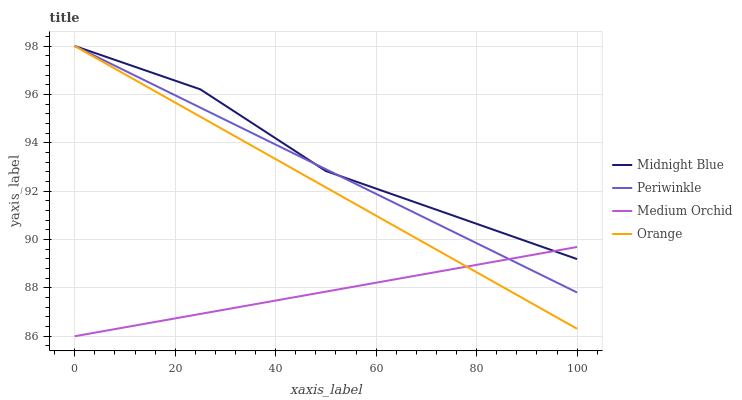Does Medium Orchid have the minimum area under the curve?
Answer yes or no. Yes. Does Midnight Blue have the maximum area under the curve?
Answer yes or no. Yes. Does Periwinkle have the minimum area under the curve?
Answer yes or no. No. Does Periwinkle have the maximum area under the curve?
Answer yes or no. No. Is Orange the smoothest?
Answer yes or no. Yes. Is Midnight Blue the roughest?
Answer yes or no. Yes. Is Medium Orchid the smoothest?
Answer yes or no. No. Is Medium Orchid the roughest?
Answer yes or no. No. Does Medium Orchid have the lowest value?
Answer yes or no. Yes. Does Periwinkle have the lowest value?
Answer yes or no. No. Does Midnight Blue have the highest value?
Answer yes or no. Yes. Does Medium Orchid have the highest value?
Answer yes or no. No. Does Medium Orchid intersect Orange?
Answer yes or no. Yes. Is Medium Orchid less than Orange?
Answer yes or no. No. Is Medium Orchid greater than Orange?
Answer yes or no. No. 